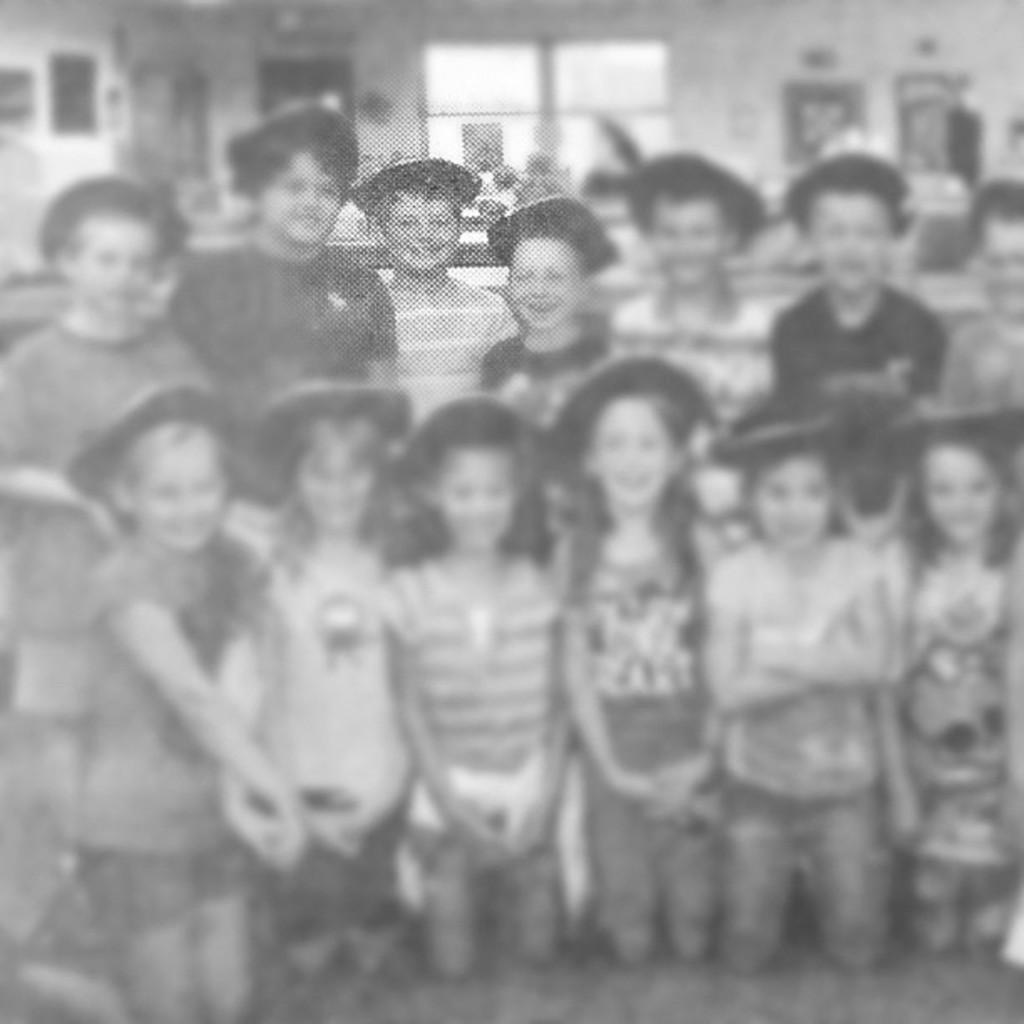How many kids are in the image? The number of kids in the image is not specified, but there are kids present. What might the kids be doing in the image? The activity of the kids in the image is not mentioned, but they are likely engaged in some form of play or interaction. What color is the crayon being used by the kids in the image? There is no crayon present in the image, so it is not possible to determine its color. 